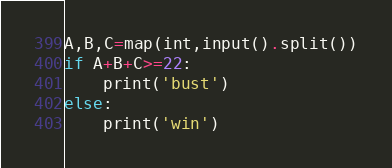Convert code to text. <code><loc_0><loc_0><loc_500><loc_500><_Python_>A,B,C=map(int,input().split())
if A+B+C>=22:
    print('bust')
else:
    print('win')</code> 